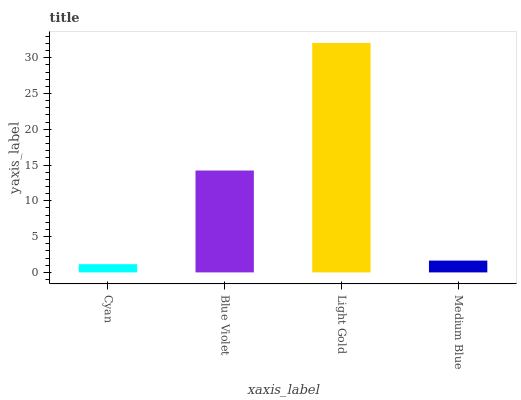Is Cyan the minimum?
Answer yes or no. Yes. Is Light Gold the maximum?
Answer yes or no. Yes. Is Blue Violet the minimum?
Answer yes or no. No. Is Blue Violet the maximum?
Answer yes or no. No. Is Blue Violet greater than Cyan?
Answer yes or no. Yes. Is Cyan less than Blue Violet?
Answer yes or no. Yes. Is Cyan greater than Blue Violet?
Answer yes or no. No. Is Blue Violet less than Cyan?
Answer yes or no. No. Is Blue Violet the high median?
Answer yes or no. Yes. Is Medium Blue the low median?
Answer yes or no. Yes. Is Light Gold the high median?
Answer yes or no. No. Is Light Gold the low median?
Answer yes or no. No. 